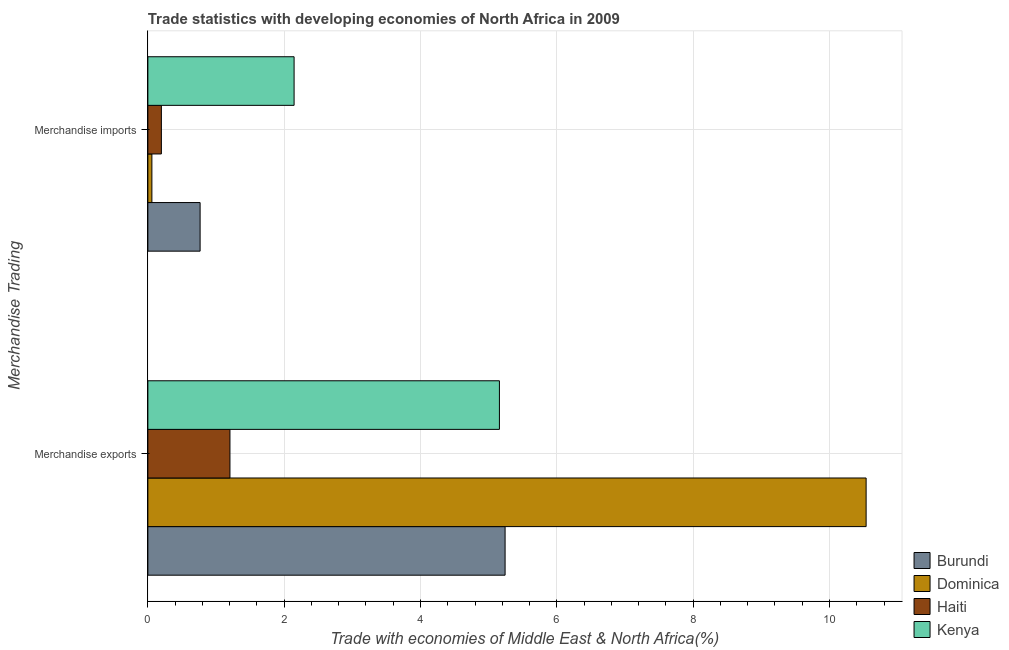How many groups of bars are there?
Offer a terse response. 2. Are the number of bars per tick equal to the number of legend labels?
Your answer should be compact. Yes. Are the number of bars on each tick of the Y-axis equal?
Your answer should be very brief. Yes. How many bars are there on the 1st tick from the top?
Give a very brief answer. 4. How many bars are there on the 1st tick from the bottom?
Give a very brief answer. 4. What is the merchandise exports in Dominica?
Provide a succinct answer. 10.54. Across all countries, what is the maximum merchandise exports?
Offer a terse response. 10.54. Across all countries, what is the minimum merchandise exports?
Keep it short and to the point. 1.2. In which country was the merchandise exports maximum?
Provide a succinct answer. Dominica. In which country was the merchandise exports minimum?
Make the answer very short. Haiti. What is the total merchandise imports in the graph?
Ensure brevity in your answer.  3.17. What is the difference between the merchandise imports in Dominica and that in Kenya?
Make the answer very short. -2.09. What is the difference between the merchandise imports in Haiti and the merchandise exports in Dominica?
Your answer should be compact. -10.34. What is the average merchandise exports per country?
Provide a short and direct response. 5.54. What is the difference between the merchandise exports and merchandise imports in Dominica?
Offer a terse response. 10.48. What is the ratio of the merchandise imports in Dominica to that in Burundi?
Give a very brief answer. 0.08. Is the merchandise exports in Kenya less than that in Haiti?
Offer a very short reply. No. In how many countries, is the merchandise exports greater than the average merchandise exports taken over all countries?
Provide a short and direct response. 1. What does the 3rd bar from the top in Merchandise imports represents?
Give a very brief answer. Dominica. What does the 4th bar from the bottom in Merchandise exports represents?
Your answer should be compact. Kenya. Does the graph contain any zero values?
Offer a terse response. No. Does the graph contain grids?
Your answer should be very brief. Yes. Where does the legend appear in the graph?
Your answer should be compact. Bottom right. How many legend labels are there?
Give a very brief answer. 4. How are the legend labels stacked?
Your response must be concise. Vertical. What is the title of the graph?
Give a very brief answer. Trade statistics with developing economies of North Africa in 2009. What is the label or title of the X-axis?
Provide a short and direct response. Trade with economies of Middle East & North Africa(%). What is the label or title of the Y-axis?
Make the answer very short. Merchandise Trading. What is the Trade with economies of Middle East & North Africa(%) in Burundi in Merchandise exports?
Provide a succinct answer. 5.24. What is the Trade with economies of Middle East & North Africa(%) in Dominica in Merchandise exports?
Offer a very short reply. 10.54. What is the Trade with economies of Middle East & North Africa(%) of Haiti in Merchandise exports?
Provide a succinct answer. 1.2. What is the Trade with economies of Middle East & North Africa(%) of Kenya in Merchandise exports?
Give a very brief answer. 5.16. What is the Trade with economies of Middle East & North Africa(%) of Burundi in Merchandise imports?
Provide a succinct answer. 0.77. What is the Trade with economies of Middle East & North Africa(%) of Dominica in Merchandise imports?
Give a very brief answer. 0.06. What is the Trade with economies of Middle East & North Africa(%) in Haiti in Merchandise imports?
Offer a terse response. 0.2. What is the Trade with economies of Middle East & North Africa(%) of Kenya in Merchandise imports?
Your response must be concise. 2.15. Across all Merchandise Trading, what is the maximum Trade with economies of Middle East & North Africa(%) in Burundi?
Your answer should be very brief. 5.24. Across all Merchandise Trading, what is the maximum Trade with economies of Middle East & North Africa(%) of Dominica?
Keep it short and to the point. 10.54. Across all Merchandise Trading, what is the maximum Trade with economies of Middle East & North Africa(%) in Haiti?
Offer a terse response. 1.2. Across all Merchandise Trading, what is the maximum Trade with economies of Middle East & North Africa(%) in Kenya?
Your answer should be very brief. 5.16. Across all Merchandise Trading, what is the minimum Trade with economies of Middle East & North Africa(%) in Burundi?
Offer a terse response. 0.77. Across all Merchandise Trading, what is the minimum Trade with economies of Middle East & North Africa(%) in Dominica?
Provide a short and direct response. 0.06. Across all Merchandise Trading, what is the minimum Trade with economies of Middle East & North Africa(%) in Haiti?
Provide a succinct answer. 0.2. Across all Merchandise Trading, what is the minimum Trade with economies of Middle East & North Africa(%) in Kenya?
Offer a very short reply. 2.15. What is the total Trade with economies of Middle East & North Africa(%) of Burundi in the graph?
Keep it short and to the point. 6.01. What is the total Trade with economies of Middle East & North Africa(%) of Dominica in the graph?
Make the answer very short. 10.6. What is the total Trade with economies of Middle East & North Africa(%) in Haiti in the graph?
Give a very brief answer. 1.4. What is the total Trade with economies of Middle East & North Africa(%) in Kenya in the graph?
Your answer should be very brief. 7.3. What is the difference between the Trade with economies of Middle East & North Africa(%) of Burundi in Merchandise exports and that in Merchandise imports?
Offer a very short reply. 4.47. What is the difference between the Trade with economies of Middle East & North Africa(%) of Dominica in Merchandise exports and that in Merchandise imports?
Offer a terse response. 10.48. What is the difference between the Trade with economies of Middle East & North Africa(%) of Haiti in Merchandise exports and that in Merchandise imports?
Make the answer very short. 1.01. What is the difference between the Trade with economies of Middle East & North Africa(%) in Kenya in Merchandise exports and that in Merchandise imports?
Ensure brevity in your answer.  3.01. What is the difference between the Trade with economies of Middle East & North Africa(%) in Burundi in Merchandise exports and the Trade with economies of Middle East & North Africa(%) in Dominica in Merchandise imports?
Give a very brief answer. 5.18. What is the difference between the Trade with economies of Middle East & North Africa(%) in Burundi in Merchandise exports and the Trade with economies of Middle East & North Africa(%) in Haiti in Merchandise imports?
Keep it short and to the point. 5.04. What is the difference between the Trade with economies of Middle East & North Africa(%) in Burundi in Merchandise exports and the Trade with economies of Middle East & North Africa(%) in Kenya in Merchandise imports?
Your response must be concise. 3.1. What is the difference between the Trade with economies of Middle East & North Africa(%) of Dominica in Merchandise exports and the Trade with economies of Middle East & North Africa(%) of Haiti in Merchandise imports?
Offer a very short reply. 10.34. What is the difference between the Trade with economies of Middle East & North Africa(%) of Dominica in Merchandise exports and the Trade with economies of Middle East & North Africa(%) of Kenya in Merchandise imports?
Offer a very short reply. 8.39. What is the difference between the Trade with economies of Middle East & North Africa(%) in Haiti in Merchandise exports and the Trade with economies of Middle East & North Africa(%) in Kenya in Merchandise imports?
Provide a short and direct response. -0.94. What is the average Trade with economies of Middle East & North Africa(%) of Burundi per Merchandise Trading?
Offer a terse response. 3. What is the average Trade with economies of Middle East & North Africa(%) of Dominica per Merchandise Trading?
Keep it short and to the point. 5.3. What is the average Trade with economies of Middle East & North Africa(%) of Haiti per Merchandise Trading?
Offer a very short reply. 0.7. What is the average Trade with economies of Middle East & North Africa(%) of Kenya per Merchandise Trading?
Provide a succinct answer. 3.65. What is the difference between the Trade with economies of Middle East & North Africa(%) of Burundi and Trade with economies of Middle East & North Africa(%) of Dominica in Merchandise exports?
Ensure brevity in your answer.  -5.3. What is the difference between the Trade with economies of Middle East & North Africa(%) in Burundi and Trade with economies of Middle East & North Africa(%) in Haiti in Merchandise exports?
Your answer should be very brief. 4.04. What is the difference between the Trade with economies of Middle East & North Africa(%) of Burundi and Trade with economies of Middle East & North Africa(%) of Kenya in Merchandise exports?
Your answer should be very brief. 0.08. What is the difference between the Trade with economies of Middle East & North Africa(%) of Dominica and Trade with economies of Middle East & North Africa(%) of Haiti in Merchandise exports?
Your answer should be compact. 9.33. What is the difference between the Trade with economies of Middle East & North Africa(%) of Dominica and Trade with economies of Middle East & North Africa(%) of Kenya in Merchandise exports?
Your answer should be very brief. 5.38. What is the difference between the Trade with economies of Middle East & North Africa(%) of Haiti and Trade with economies of Middle East & North Africa(%) of Kenya in Merchandise exports?
Offer a terse response. -3.95. What is the difference between the Trade with economies of Middle East & North Africa(%) in Burundi and Trade with economies of Middle East & North Africa(%) in Dominica in Merchandise imports?
Offer a terse response. 0.71. What is the difference between the Trade with economies of Middle East & North Africa(%) of Burundi and Trade with economies of Middle East & North Africa(%) of Haiti in Merchandise imports?
Your answer should be compact. 0.57. What is the difference between the Trade with economies of Middle East & North Africa(%) of Burundi and Trade with economies of Middle East & North Africa(%) of Kenya in Merchandise imports?
Your response must be concise. -1.38. What is the difference between the Trade with economies of Middle East & North Africa(%) in Dominica and Trade with economies of Middle East & North Africa(%) in Haiti in Merchandise imports?
Give a very brief answer. -0.14. What is the difference between the Trade with economies of Middle East & North Africa(%) of Dominica and Trade with economies of Middle East & North Africa(%) of Kenya in Merchandise imports?
Your response must be concise. -2.09. What is the difference between the Trade with economies of Middle East & North Africa(%) in Haiti and Trade with economies of Middle East & North Africa(%) in Kenya in Merchandise imports?
Give a very brief answer. -1.95. What is the ratio of the Trade with economies of Middle East & North Africa(%) of Burundi in Merchandise exports to that in Merchandise imports?
Your answer should be very brief. 6.84. What is the ratio of the Trade with economies of Middle East & North Africa(%) of Dominica in Merchandise exports to that in Merchandise imports?
Offer a terse response. 178.29. What is the ratio of the Trade with economies of Middle East & North Africa(%) in Haiti in Merchandise exports to that in Merchandise imports?
Offer a terse response. 6.08. What is the ratio of the Trade with economies of Middle East & North Africa(%) of Kenya in Merchandise exports to that in Merchandise imports?
Give a very brief answer. 2.4. What is the difference between the highest and the second highest Trade with economies of Middle East & North Africa(%) in Burundi?
Provide a succinct answer. 4.47. What is the difference between the highest and the second highest Trade with economies of Middle East & North Africa(%) of Dominica?
Your answer should be very brief. 10.48. What is the difference between the highest and the second highest Trade with economies of Middle East & North Africa(%) in Kenya?
Make the answer very short. 3.01. What is the difference between the highest and the lowest Trade with economies of Middle East & North Africa(%) in Burundi?
Offer a very short reply. 4.47. What is the difference between the highest and the lowest Trade with economies of Middle East & North Africa(%) in Dominica?
Ensure brevity in your answer.  10.48. What is the difference between the highest and the lowest Trade with economies of Middle East & North Africa(%) in Kenya?
Your answer should be very brief. 3.01. 